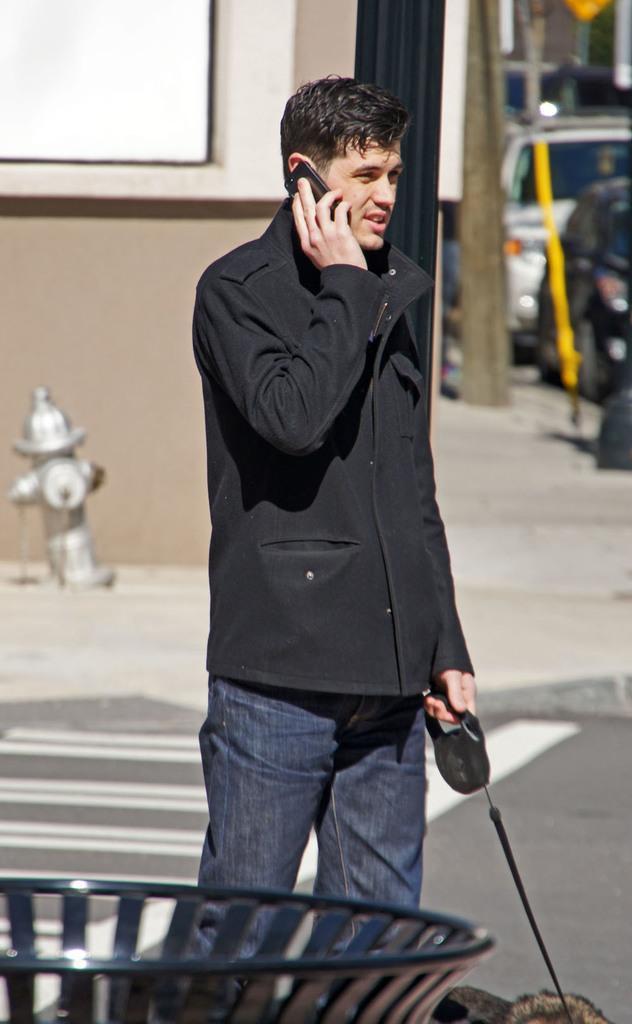In one or two sentences, can you explain what this image depicts? In this image we can see a person holding a dog and a mobile phone, there are some vehicles, buildings, hydrant and poles. 